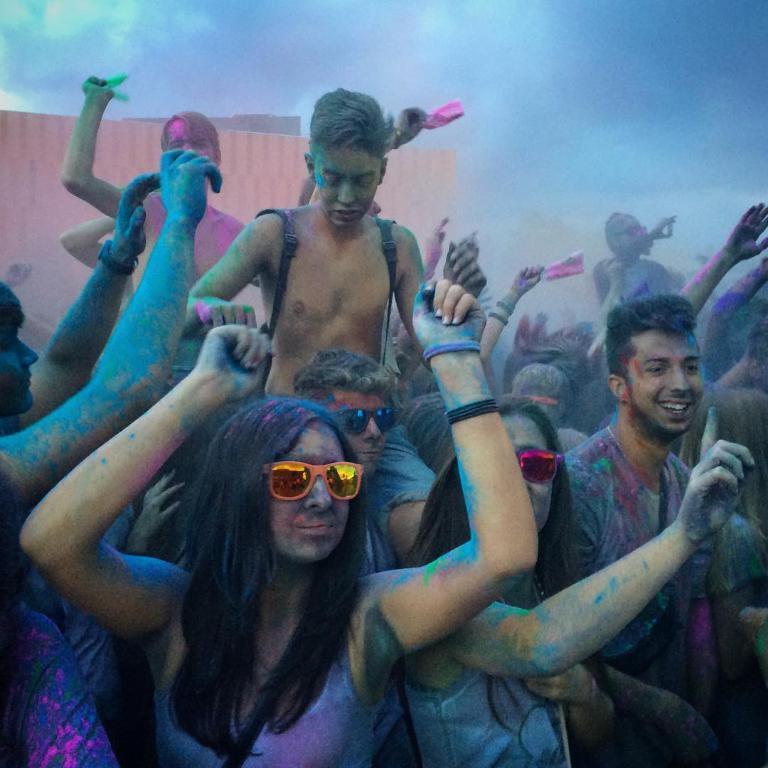Can you describe this image briefly? In the center of the image we can see a few people are playing with colors. Among them, we can see a few people are wearing glasses, one person is smiling, few people are holding a few persons and a few people are holding some objects. In the background, we can see a few other objects. 